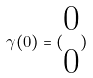<formula> <loc_0><loc_0><loc_500><loc_500>\gamma ( 0 ) = ( \begin{matrix} 0 \\ 0 \end{matrix} )</formula> 